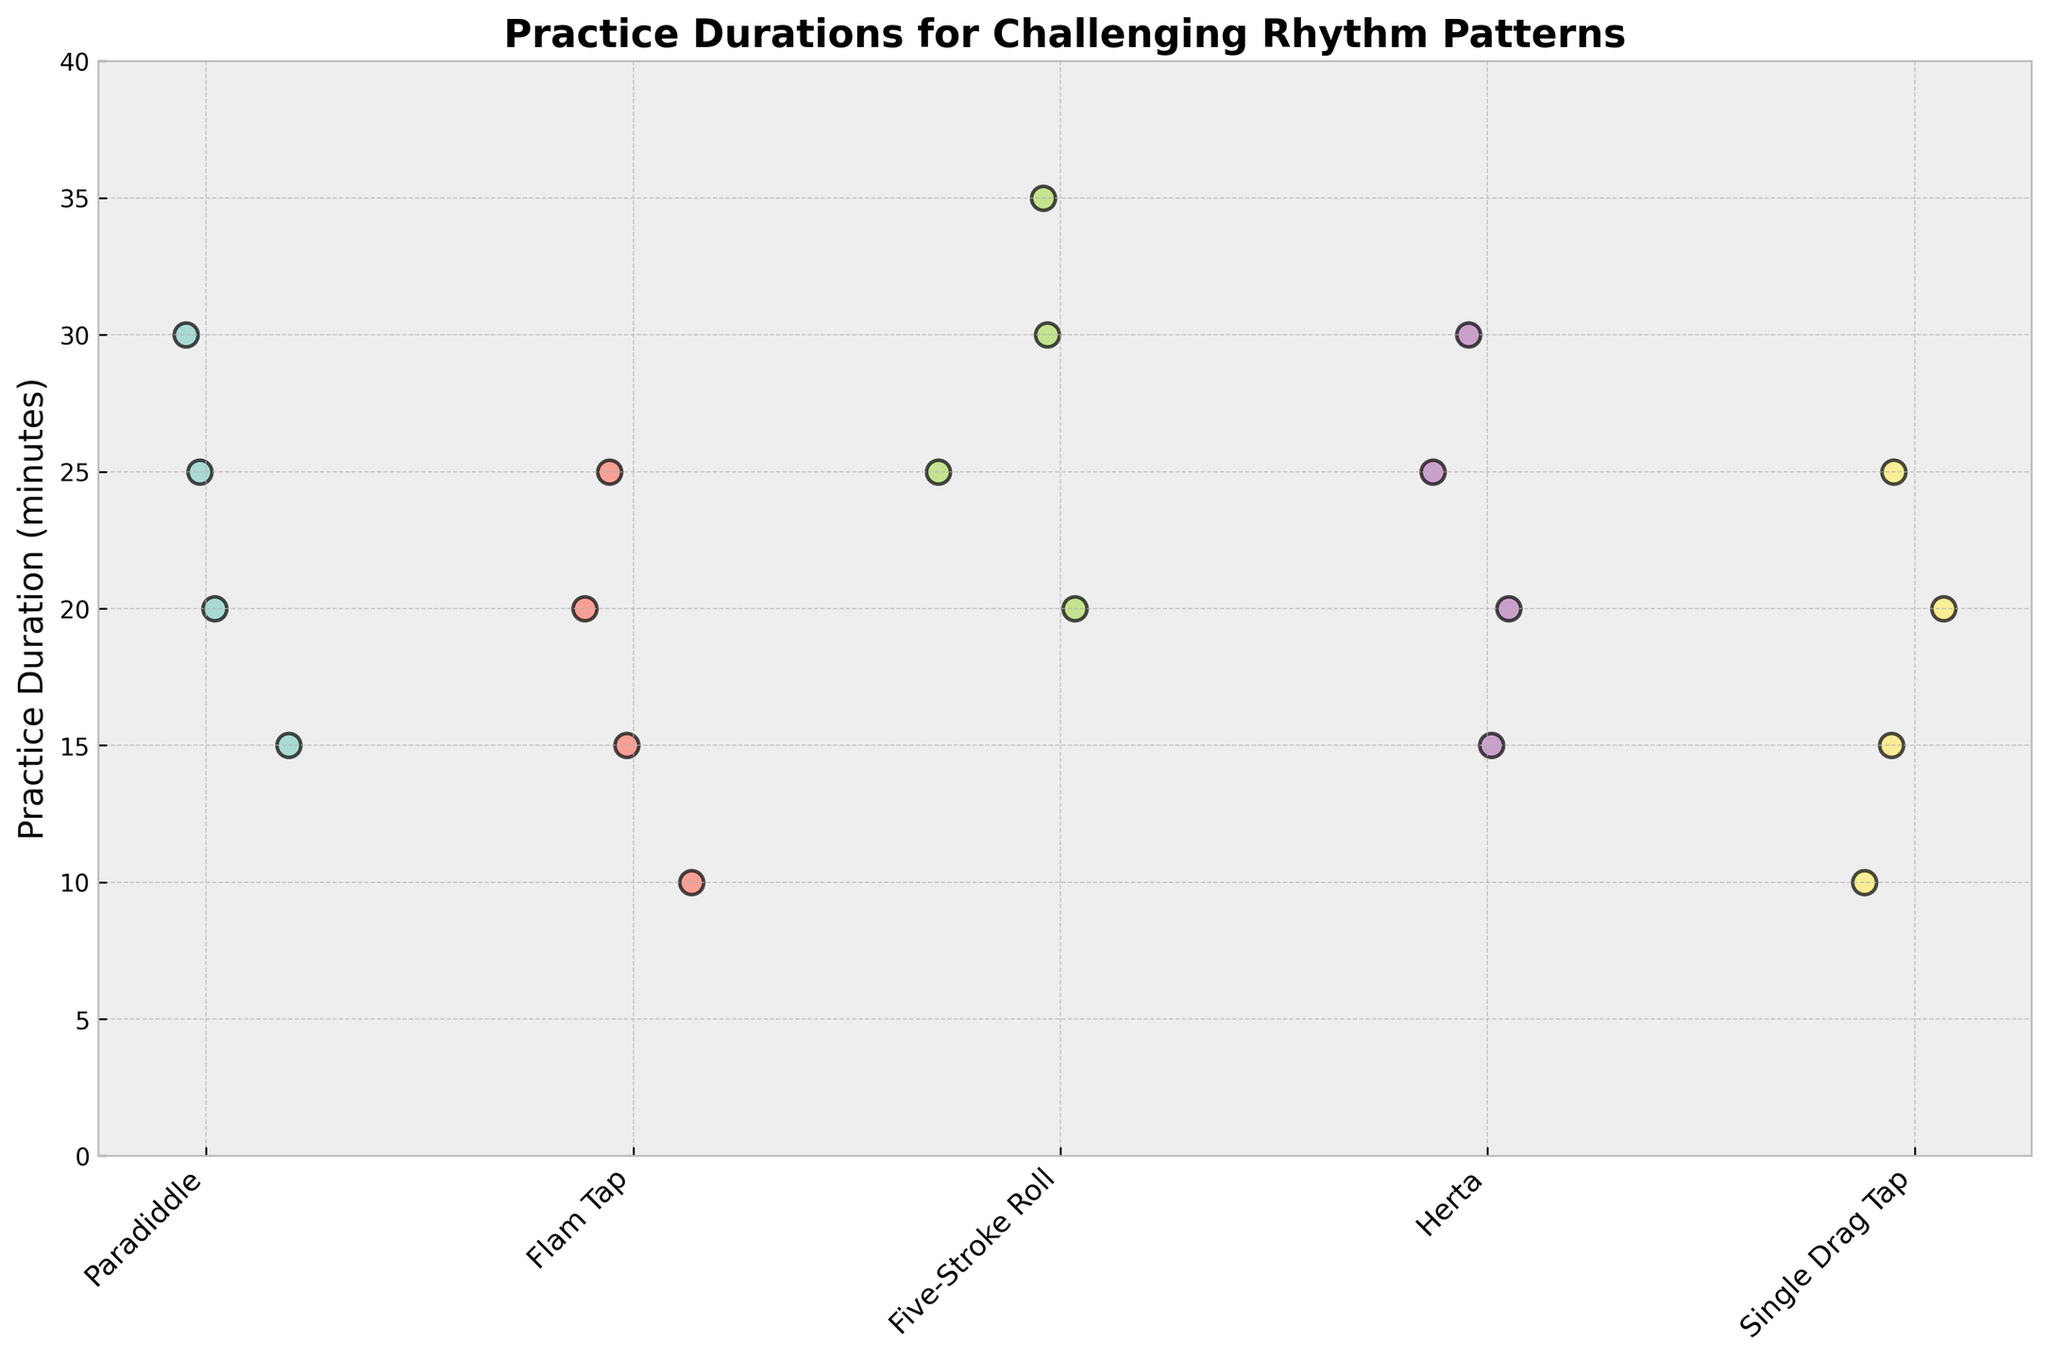What's the title of the figure? The title is typically located at the top of a chart and is designed to summarize its content. In this figure, the title is clearly written on top.
Answer: Practice Durations for Challenging Rhythm Patterns What is the range of practice durations shown? The y-axis represents practice durations and its range is indicated by the labels and the grid lines. The minimum value on the y-axis is 0 and the maximum value extends just above 35.
Answer: 0 to 35 minutes How many rhythm patterns are displayed in the plot? Each unique rhythm pattern is represented by a distinct scatter point set along specific positions on the x-axis. Counting these groups provides the answer.
Answer: 5 Which rhythm pattern has the highest practice duration? By locating the highest point on the y-axis and checking which group it belongs to, we find the longest practice duration. The highest point in this figure reaches 35 and belongs to the group labeled Five-Stroke Roll.
Answer: Five-Stroke Roll What is the average practice duration for the Paradiddle pattern? To find the average, sum all practice durations for Paradiddle (15 + 20 + 25 + 30) and divide by the number of observations (4).
Answer: 22.5 Which rhythm pattern has the least variation in practice duration? Variation in practice duration can be visually assessed by looking for the narrowest spread of points in each group. The Flam Tap pattern shows the least variation, with points close to each other within the 10-25 minutes range.
Answer: Flam Tap Compare the practice durations for Herta and Single Drag Tap. Which pattern generally requires more practice? General trends in practice durations can be observed by comparing the cluster of points. Both Herta and Single Drag Tap have maximum practice durations at 30 and 25 respectively, but all points for Herta are at or above 15 while Single Drag Tap also includes points at 10 minutes. This indicates that Herta generally requires more practice.
Answer: Herta What is the practice duration range for the Five-Stroke Roll pattern? To find the range, we identify the minimum and maximum practice durations for this pattern, which appear to be 20 and 35 minutes respectively. The range is the difference between these values.
Answer: 20 to 35 minutes Which rhythm patterns have a practice duration point at 30 minutes? By identifying the data points lying at 30 minutes on the y-axis, we see they belong to Paradiddle, Five-Stroke Roll, and Herta patterns.
Answer: Paradiddle, Five-Stroke Roll, Herta 